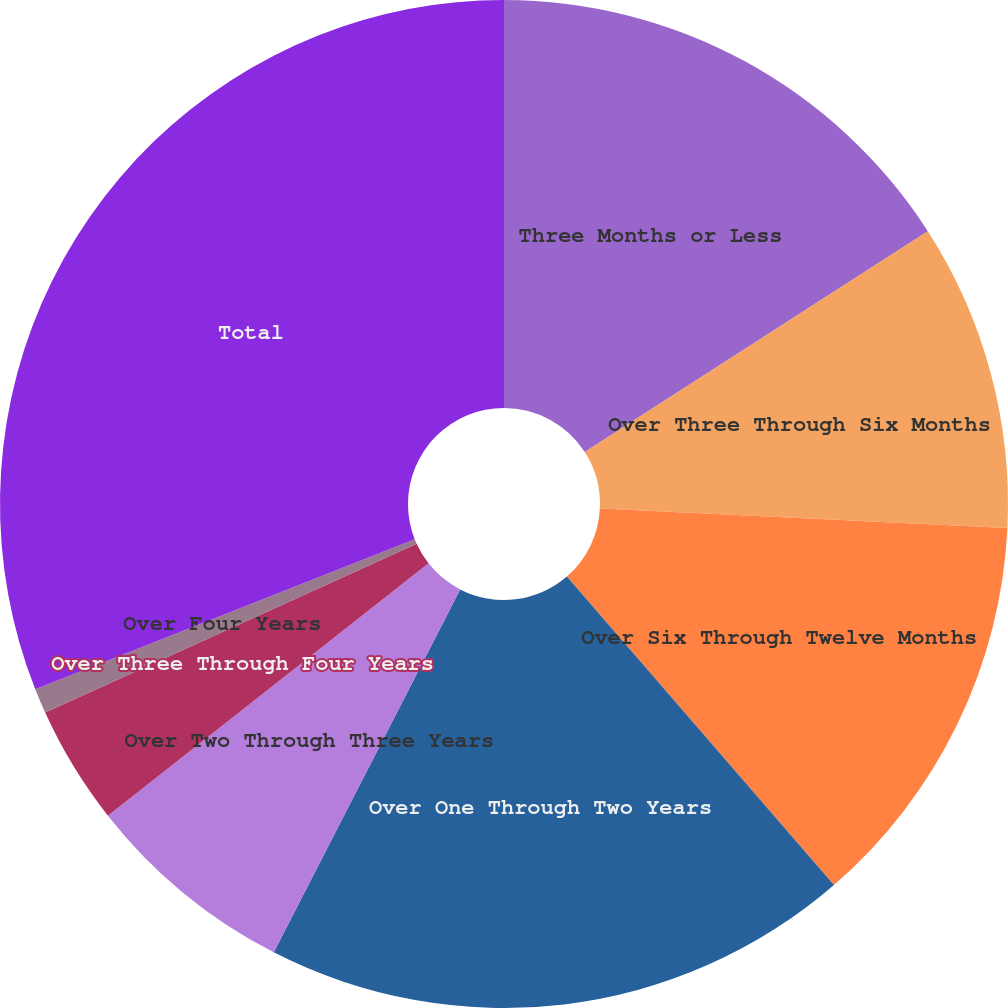Convert chart. <chart><loc_0><loc_0><loc_500><loc_500><pie_chart><fcel>Three Months or Less<fcel>Over Three Through Six Months<fcel>Over Six Through Twelve Months<fcel>Over One Through Two Years<fcel>Over Two Through Three Years<fcel>Over Three Through Four Years<fcel>Over Four Years<fcel>Total<nl><fcel>15.9%<fcel>9.86%<fcel>12.88%<fcel>18.91%<fcel>6.84%<fcel>3.82%<fcel>0.8%<fcel>30.99%<nl></chart> 